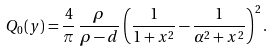<formula> <loc_0><loc_0><loc_500><loc_500>Q _ { 0 } ( y ) = \frac { 4 } { \pi } \, \frac { \rho } { \rho - d } \left ( \frac { 1 } { 1 + x ^ { 2 } } - \frac { 1 } { \alpha ^ { 2 } + x ^ { 2 } } \right ) ^ { 2 } .</formula> 